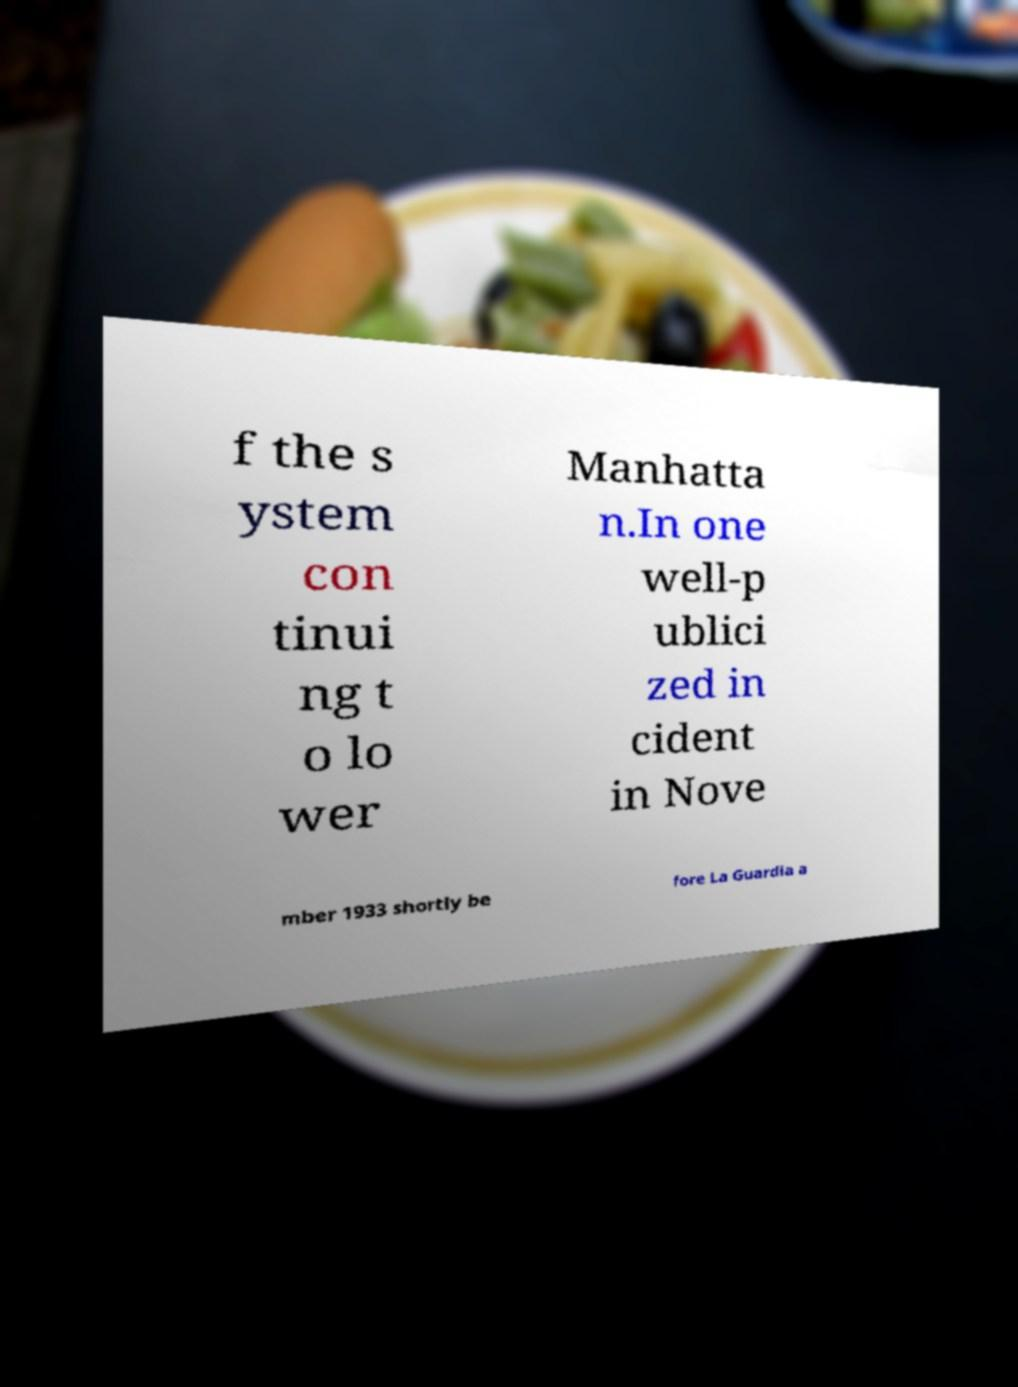There's text embedded in this image that I need extracted. Can you transcribe it verbatim? f the s ystem con tinui ng t o lo wer Manhatta n.In one well-p ublici zed in cident in Nove mber 1933 shortly be fore La Guardia a 